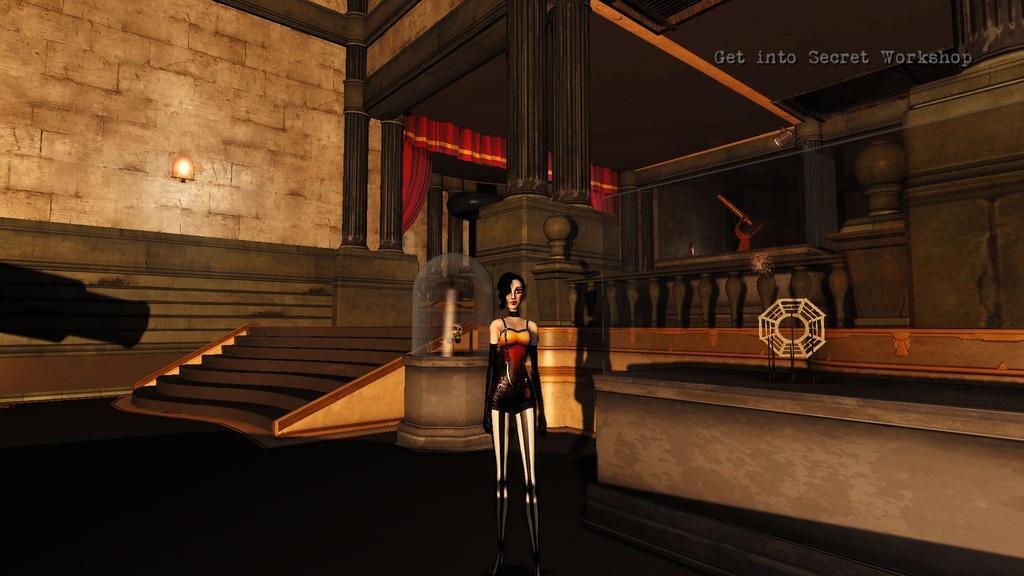Can you describe this image briefly? In this image there is a depiction of a person standing on the floor. On the right side of the image there is a table. On top of it there is some object. On the left side of the image there are stairs. There is a wall. There are curtains. On the right side of the image there is a railing. There is some text on the right side of the image. 